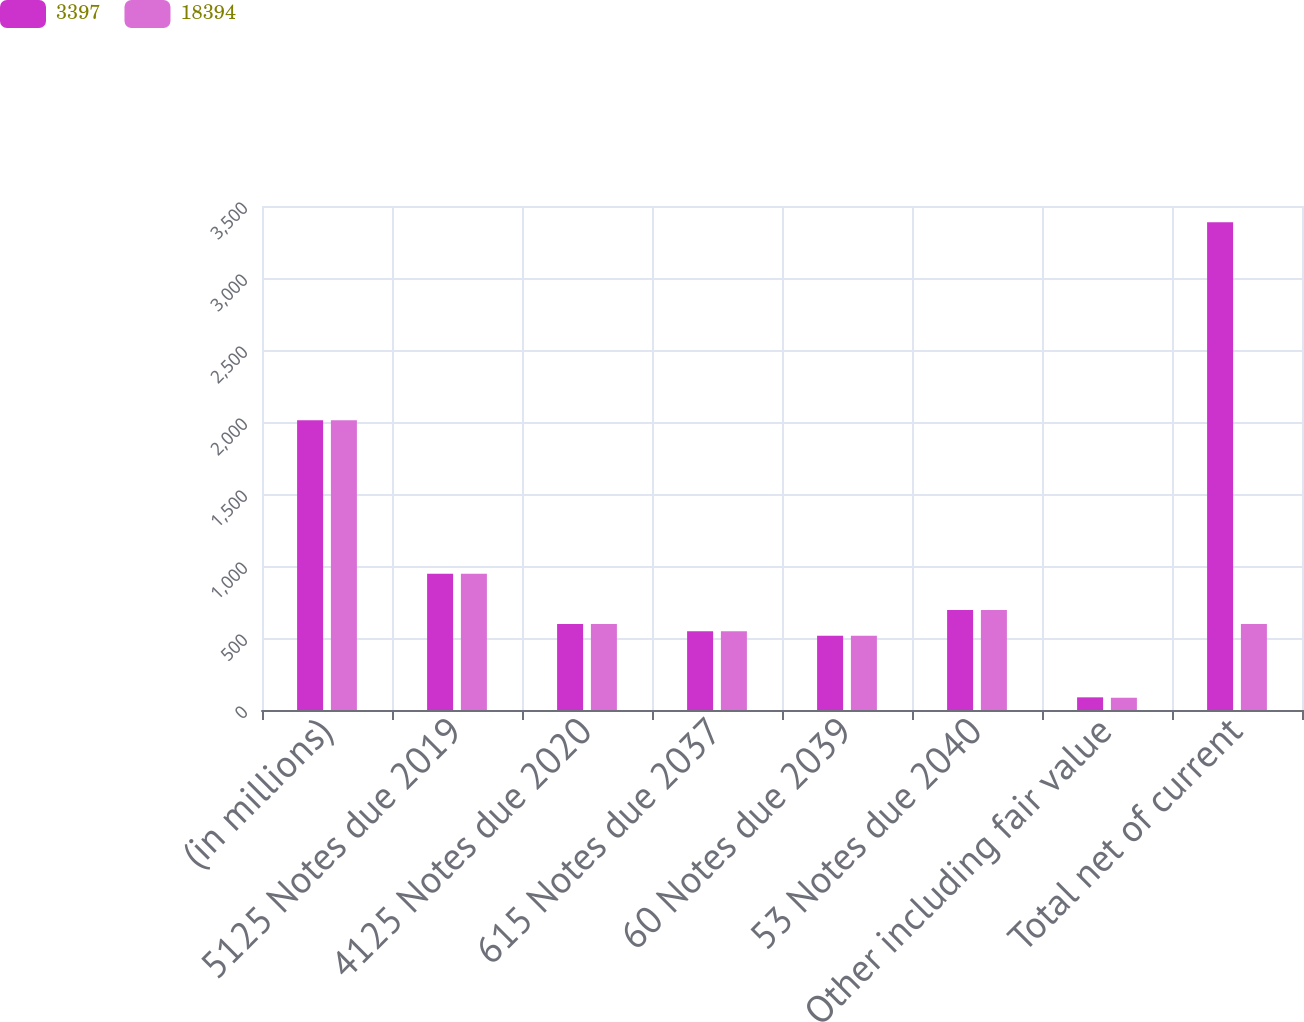<chart> <loc_0><loc_0><loc_500><loc_500><stacked_bar_chart><ecel><fcel>(in millions)<fcel>5125 Notes due 2019<fcel>4125 Notes due 2020<fcel>615 Notes due 2037<fcel>60 Notes due 2039<fcel>53 Notes due 2040<fcel>Other including fair value<fcel>Total net of current<nl><fcel>3397<fcel>2013<fcel>947<fcel>597<fcel>547<fcel>515<fcel>694<fcel>88<fcel>3388<nl><fcel>18394<fcel>2012<fcel>947<fcel>597<fcel>547<fcel>515<fcel>694<fcel>85<fcel>597<nl></chart> 